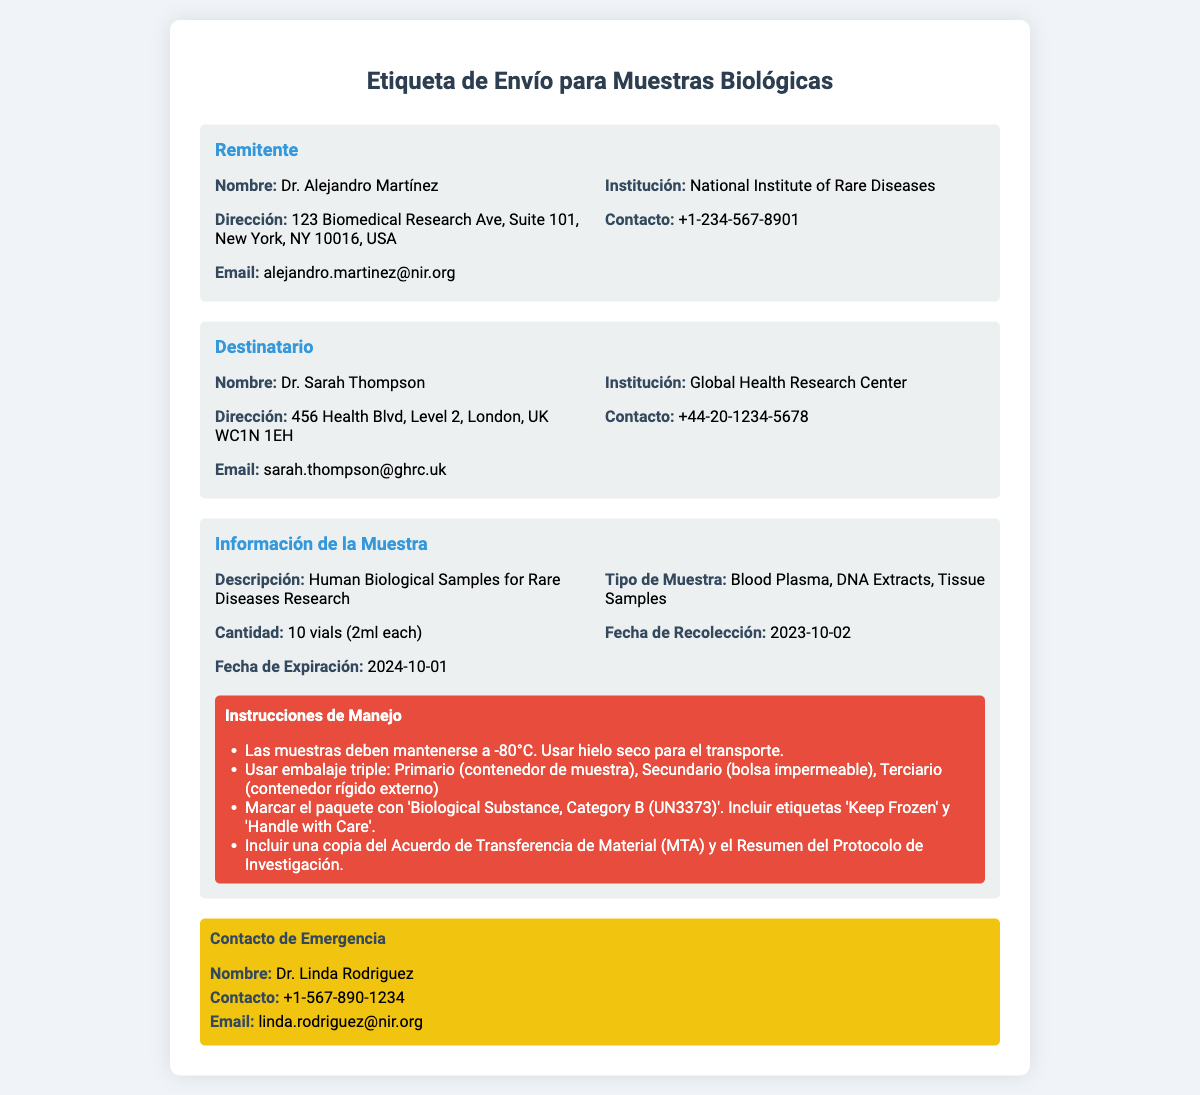¿Qué nombre tiene el remitente? El nombre del remitente es el que se encuentra en la sección correspondiente de la etiqueta, indica quién envía la muestra.
Answer: Dr. Alejandro Martínez ¿Cuál es la dirección del destinatario? La dirección del destinatario se encuentra en la sección de "Destinatario" y es importante para el envío correcto de las muestras.
Answer: 456 Health Blvd, Level 2, London, UK WC1N 1EH ¿Cuántas viales de muestra se envían? La cantidad de viales está especificada en la sección "Información de la Muestra" y es fundamental para el seguimiento de las muestras enviadas.
Answer: 10 vials (2ml each) ¿Cuál es la fecha de expiración de las muestras? Esta fecha es relevante para asegurar que las muestras se manejen y utilicen antes de que pierdan su efectividad.
Answer: 2024-10-01 ¿Qué temperatura deben mantener las muestras? La temperatura de almacenamiento es crucial para la conservación de las muestras y se indica en las instrucciones de manejo.
Answer: -80°C ¿Por qué tipo de embalaje hay que utilizar? El embalaje adecuado asegura la integridad de las muestras durante el transporte y se menciona explícitamente en las instrucciones de manejo.
Answer: Embalaje triple ¿Cuál es el contenido del contacto de emergencia? Este contacto es importante para resolver cualquier problema que pueda surgir durante el transporte de las muestras.
Answer: Dr. Linda Rodriguez ¿Qué documento se debe incluir con el paquete? Llevar la documentación adecuada es esencial para el envío de las muestras biológicas, garantizando que se sigan los procedimientos correctos.
Answer: Acuerdo de Transferencia de Material (MTA) ¿Qué contacto se debe utilizar para comunicación durante el envío? Conocer el contacto para emergencias puede ser vital en caso de problemas durante el envío.
Answer: +1-567-890-1234 